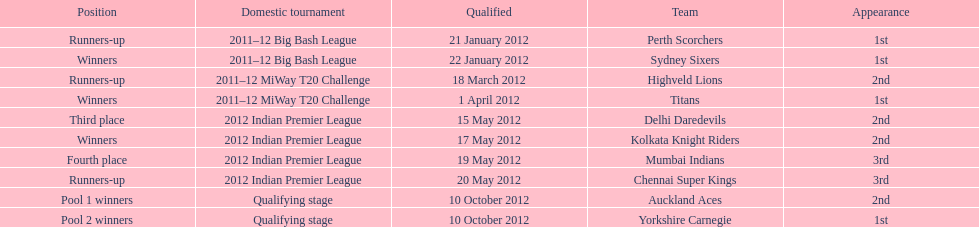The auckland aces and yorkshire carnegie qualified on what date? 10 October 2012. 